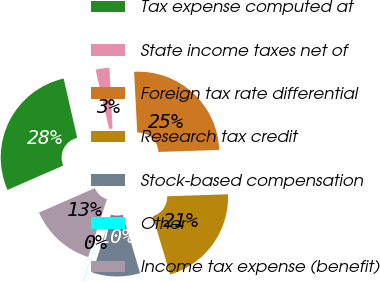<chart> <loc_0><loc_0><loc_500><loc_500><pie_chart><fcel>Tax expense computed at<fcel>State income taxes net of<fcel>Foreign tax rate differential<fcel>Research tax credit<fcel>Stock-based compensation<fcel>Other<fcel>Income tax expense (benefit)<nl><fcel>28.0%<fcel>2.75%<fcel>25.3%<fcel>20.94%<fcel>9.51%<fcel>0.05%<fcel>13.45%<nl></chart> 